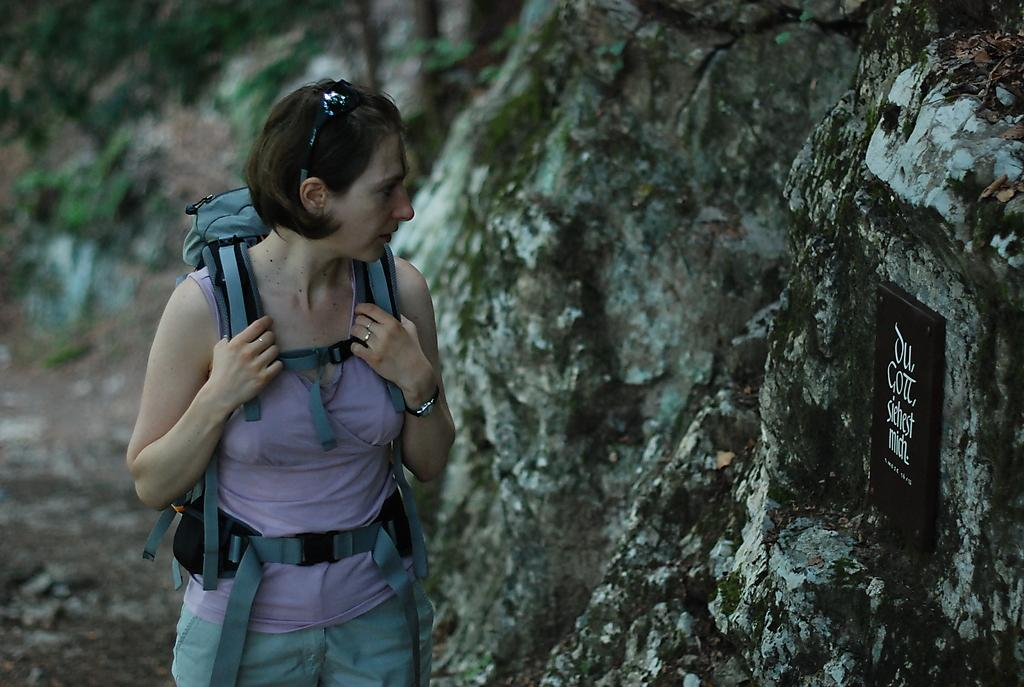Who is the main subject in the image? There is a woman in the image. What is the woman doing in the image? The woman is standing in the image. What is the woman looking at in the image? The woman is looking at a tile in the image. Where is the tile located in the image? The tile is on a hill in the image. What type of behavior is the woman exhibiting towards the coast in the image? There is no coast present in the image, so it is not possible to determine the woman's behavior towards it. 